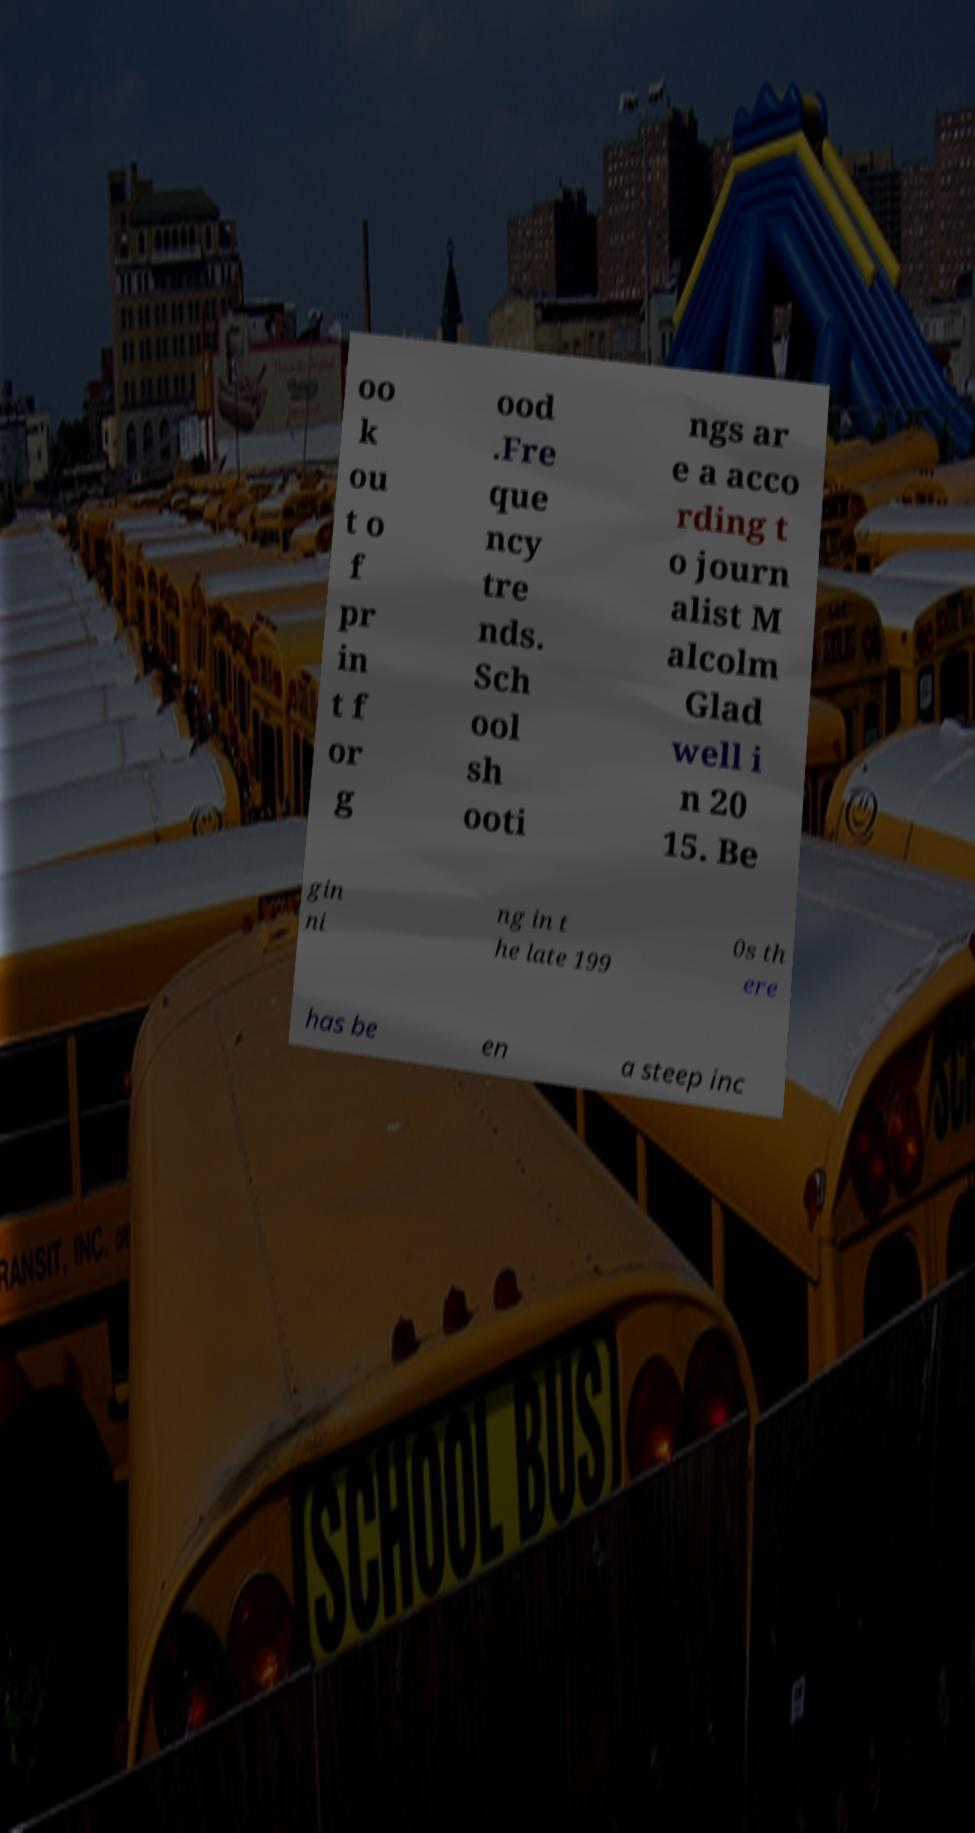I need the written content from this picture converted into text. Can you do that? oo k ou t o f pr in t f or g ood .Fre que ncy tre nds. Sch ool sh ooti ngs ar e a acco rding t o journ alist M alcolm Glad well i n 20 15. Be gin ni ng in t he late 199 0s th ere has be en a steep inc 